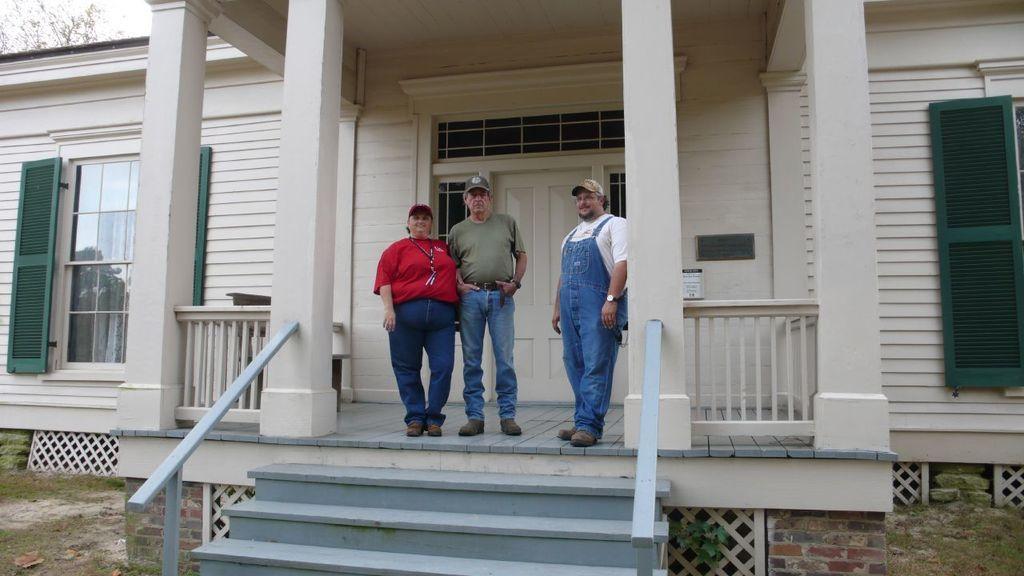Can you describe this image briefly? In this image there are three person standing at middle of this image. The right side person is wearing white color t shirt and blue color jeans and there is a person in middle side wearing a cap and left side person is wearing red color t shirt and jeans and there is a building in the background. There is a window at left side of this image and right side of this image as well. There is a tree at top left corner of this image. 